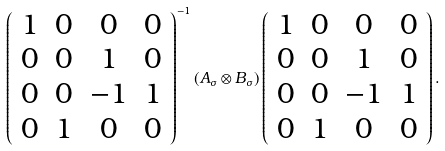Convert formula to latex. <formula><loc_0><loc_0><loc_500><loc_500>\left ( \begin{array} { c c c c } 1 & 0 & 0 & 0 \\ 0 & 0 & 1 & 0 \\ 0 & 0 & - 1 & 1 \\ 0 & 1 & 0 & 0 \\ \end{array} \right ) ^ { - 1 } ( A _ { \sigma } \otimes B _ { \sigma } ) \left ( \begin{array} { c c c c } 1 & 0 & 0 & 0 \\ 0 & 0 & 1 & 0 \\ 0 & 0 & - 1 & 1 \\ 0 & 1 & 0 & 0 \\ \end{array} \right ) .</formula> 